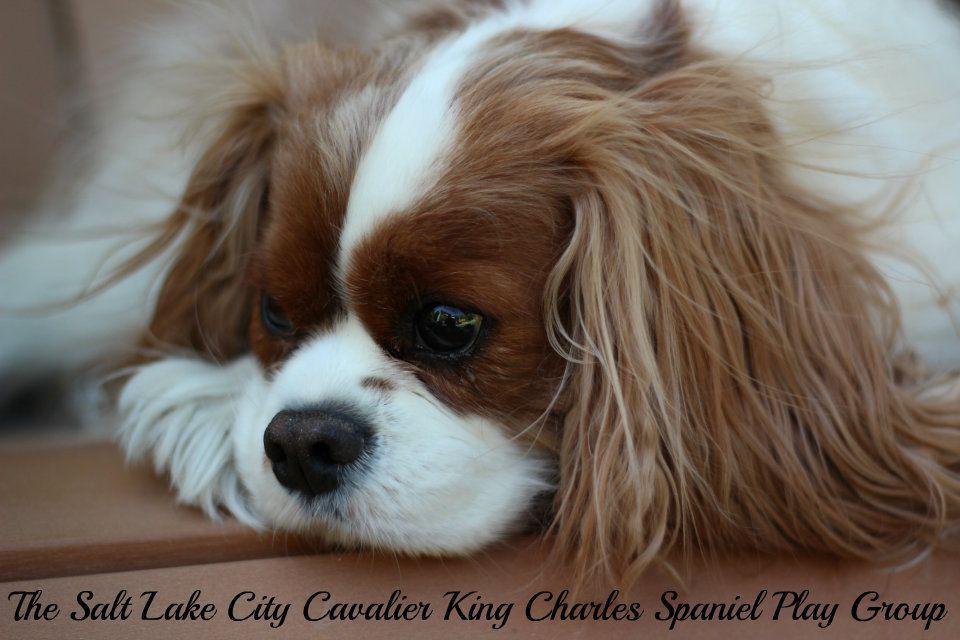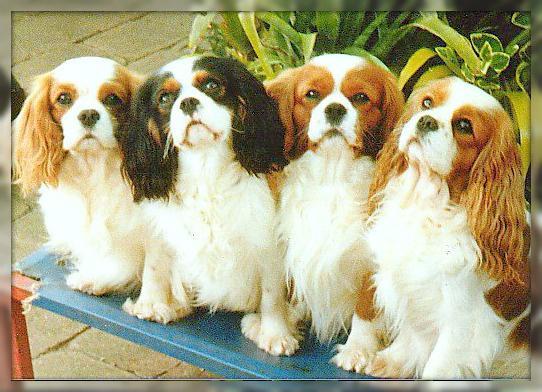The first image is the image on the left, the second image is the image on the right. Examine the images to the left and right. Is the description "There are 5 dogs shown." accurate? Answer yes or no. Yes. The first image is the image on the left, the second image is the image on the right. For the images displayed, is the sentence "There are five dogs in total, with more dogs on the right." factually correct? Answer yes or no. Yes. 